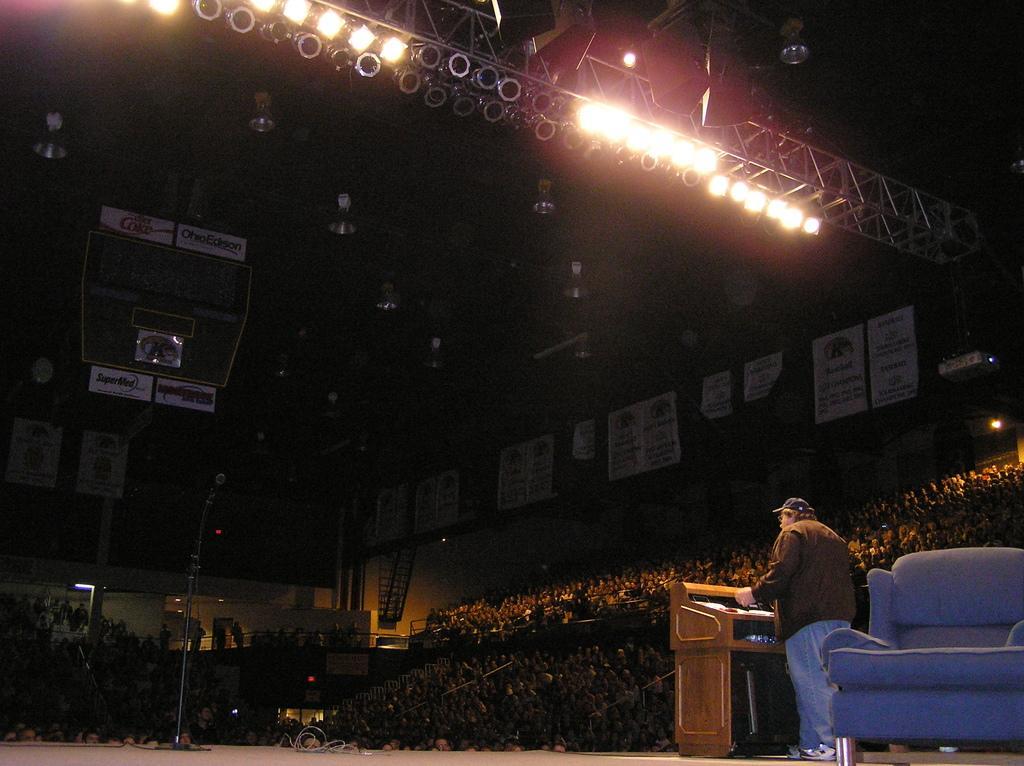Please provide a concise description of this image. In this image there is an auditorium, in that people are sitting on chairs, a man is standing on a stage, in front of a podium behind the man there is a chair, in the middle there is mic, on top there are lights and speaker. 